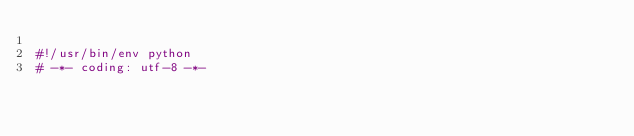Convert code to text. <code><loc_0><loc_0><loc_500><loc_500><_Python_>
#!/usr/bin/env python
# -*- coding: utf-8 -*-
</code> 